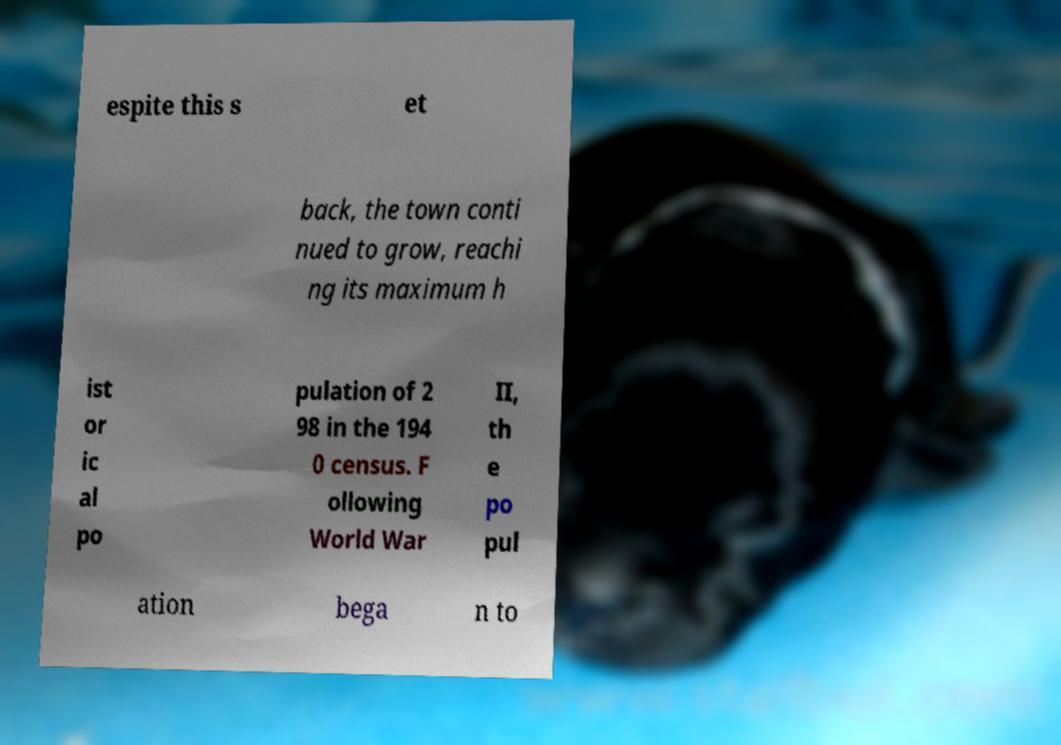Can you read and provide the text displayed in the image?This photo seems to have some interesting text. Can you extract and type it out for me? espite this s et back, the town conti nued to grow, reachi ng its maximum h ist or ic al po pulation of 2 98 in the 194 0 census. F ollowing World War II, th e po pul ation bega n to 